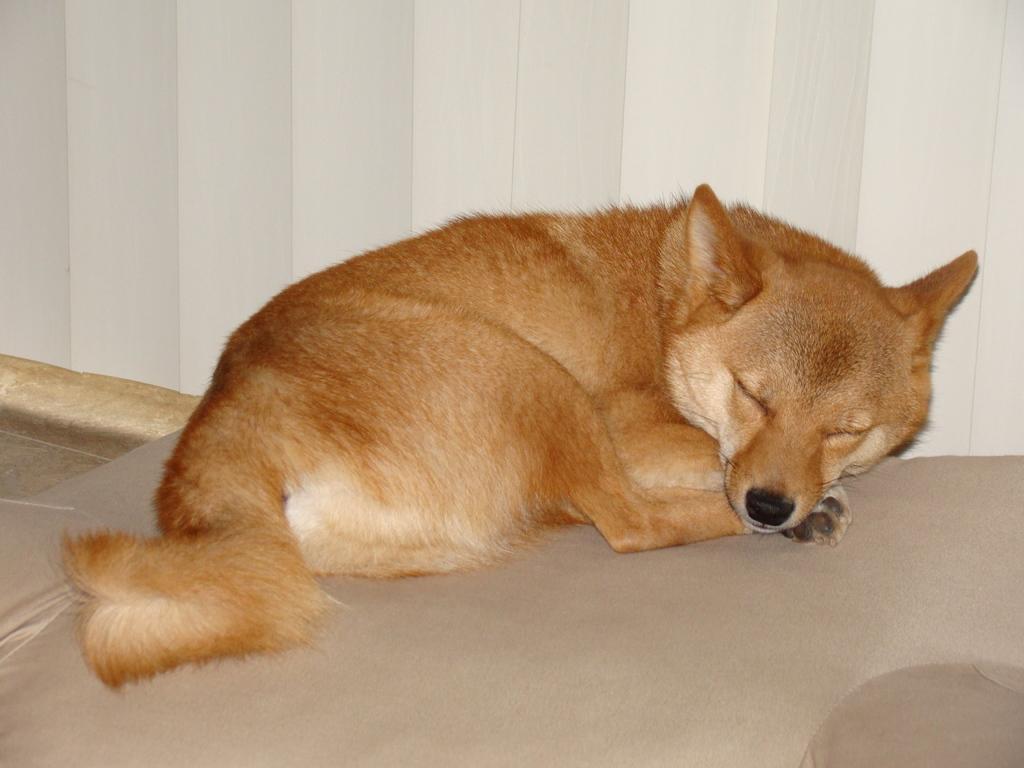In one or two sentences, can you explain what this image depicts? In the image we can see a dog, pale brown in color and the dog is sleeping on the mat. Here we can see the window blinds. 